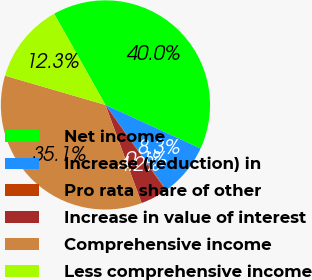Convert chart to OTSL. <chart><loc_0><loc_0><loc_500><loc_500><pie_chart><fcel>Net income<fcel>Increase (reduction) in<fcel>Pro rata share of other<fcel>Increase in value of interest<fcel>Comprehensive income<fcel>Less comprehensive income<nl><fcel>39.99%<fcel>8.26%<fcel>0.1%<fcel>4.18%<fcel>35.13%<fcel>12.34%<nl></chart> 